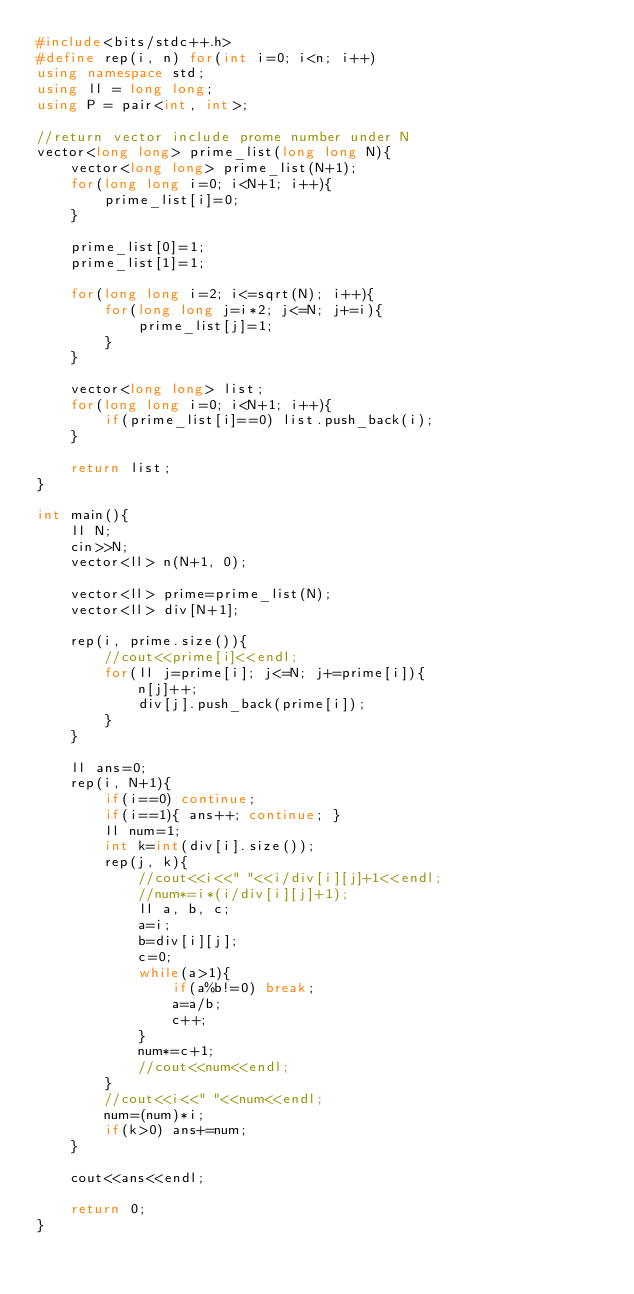Convert code to text. <code><loc_0><loc_0><loc_500><loc_500><_C++_>#include<bits/stdc++.h>
#define rep(i, n) for(int i=0; i<n; i++)
using namespace std;
using ll = long long;
using P = pair<int, int>;

//return vector include prome number under N
vector<long long> prime_list(long long N){
    vector<long long> prime_list(N+1);
    for(long long i=0; i<N+1; i++){
        prime_list[i]=0;
    }

    prime_list[0]=1;
    prime_list[1]=1;

    for(long long i=2; i<=sqrt(N); i++){
        for(long long j=i*2; j<=N; j+=i){
            prime_list[j]=1;
        }
    }

    vector<long long> list;
    for(long long i=0; i<N+1; i++){
        if(prime_list[i]==0) list.push_back(i);
    }

    return list;
}

int main(){
    ll N;
    cin>>N;
    vector<ll> n(N+1, 0);

    vector<ll> prime=prime_list(N);
    vector<ll> div[N+1];

    rep(i, prime.size()){
        //cout<<prime[i]<<endl;
        for(ll j=prime[i]; j<=N; j+=prime[i]){
            n[j]++;
            div[j].push_back(prime[i]);
        }
    }

    ll ans=0;
    rep(i, N+1){
        if(i==0) continue;
        if(i==1){ ans++; continue; }
        ll num=1;
        int k=int(div[i].size());
        rep(j, k){
            //cout<<i<<" "<<i/div[i][j]+1<<endl;
            //num*=i*(i/div[i][j]+1);
            ll a, b, c;
            a=i;
            b=div[i][j];
            c=0;
            while(a>1){
                if(a%b!=0) break;
                a=a/b;
                c++;
            }
            num*=c+1;
            //cout<<num<<endl;
        }
        //cout<<i<<" "<<num<<endl;
        num=(num)*i;
        if(k>0) ans+=num;
    }

    cout<<ans<<endl;

    return 0;
}</code> 